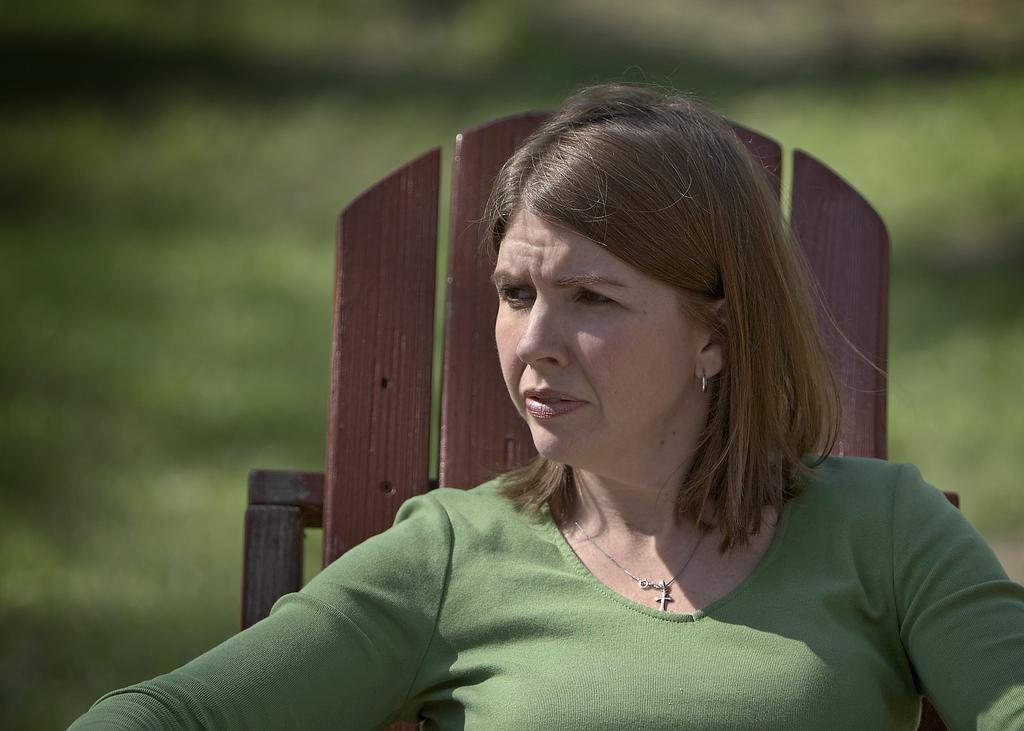How would you summarize this image in a sentence or two? In this picture we see a woman seated on a chair. She wore a green color T-shirt 